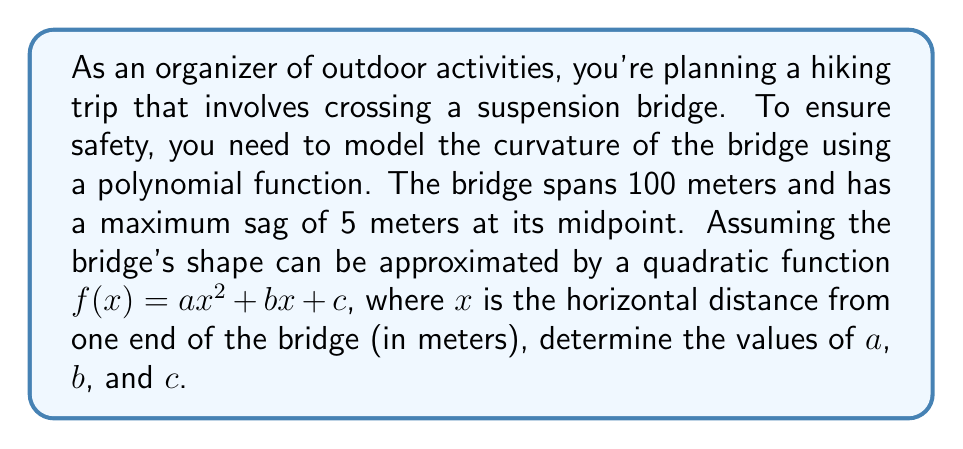Show me your answer to this math problem. Let's approach this step-by-step:

1) The quadratic function we're using is $f(x) = ax^2 + bx + c$, where $f(x)$ represents the vertical distance from the top of the supports.

2) We know three key points about this bridge:
   - At $x = 0$, $f(0) = 0$ (one end of the bridge)
   - At $x = 100$, $f(100) = 0$ (other end of the bridge)
   - At $x = 50$, $f(50) = 5$ (midpoint with maximum sag)

3) Let's use these points to set up three equations:

   Equation 1: $f(0) = a(0)^2 + b(0) + c = 0$
   Equation 2: $f(100) = a(100)^2 + b(100) + c = 0$
   Equation 3: $f(50) = a(50)^2 + b(50) + c = 5$

4) From Equation 1, we can immediately deduce that $c = 0$.

5) Substituting this into Equation 2:
   $10000a + 100b = 0$
   $100a + b = 0$
   $b = -100a$

6) Now, let's substitute these into Equation 3:
   $a(50)^2 + b(50) + 0 = 5$
   $2500a - 5000a = 5$
   $-2500a = 5$
   $a = -\frac{1}{500} = -0.002$

7) Now that we have $a$, we can find $b$:
   $b = -100a = -100(-0.002) = 0.2$

8) We already know that $c = 0$.

Therefore, the quadratic function modeling the bridge's curvature is:
$$f(x) = -0.002x^2 + 0.2x$$
Answer: $a = -0.002$, $b = 0.2$, $c = 0$ 